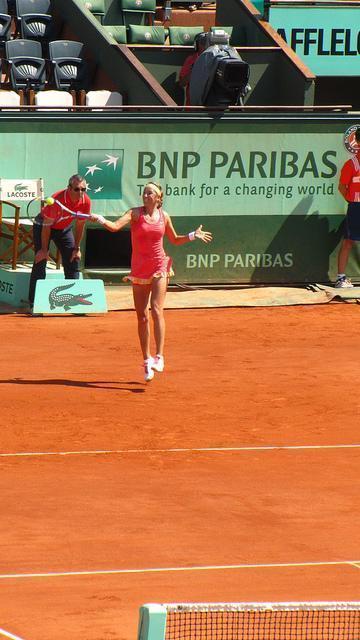What shirt brand is represented by the amphibious animal?
Answer the question by selecting the correct answer among the 4 following choices.
Options: Polo, nike, lulu lemon, adidas. Polo. 